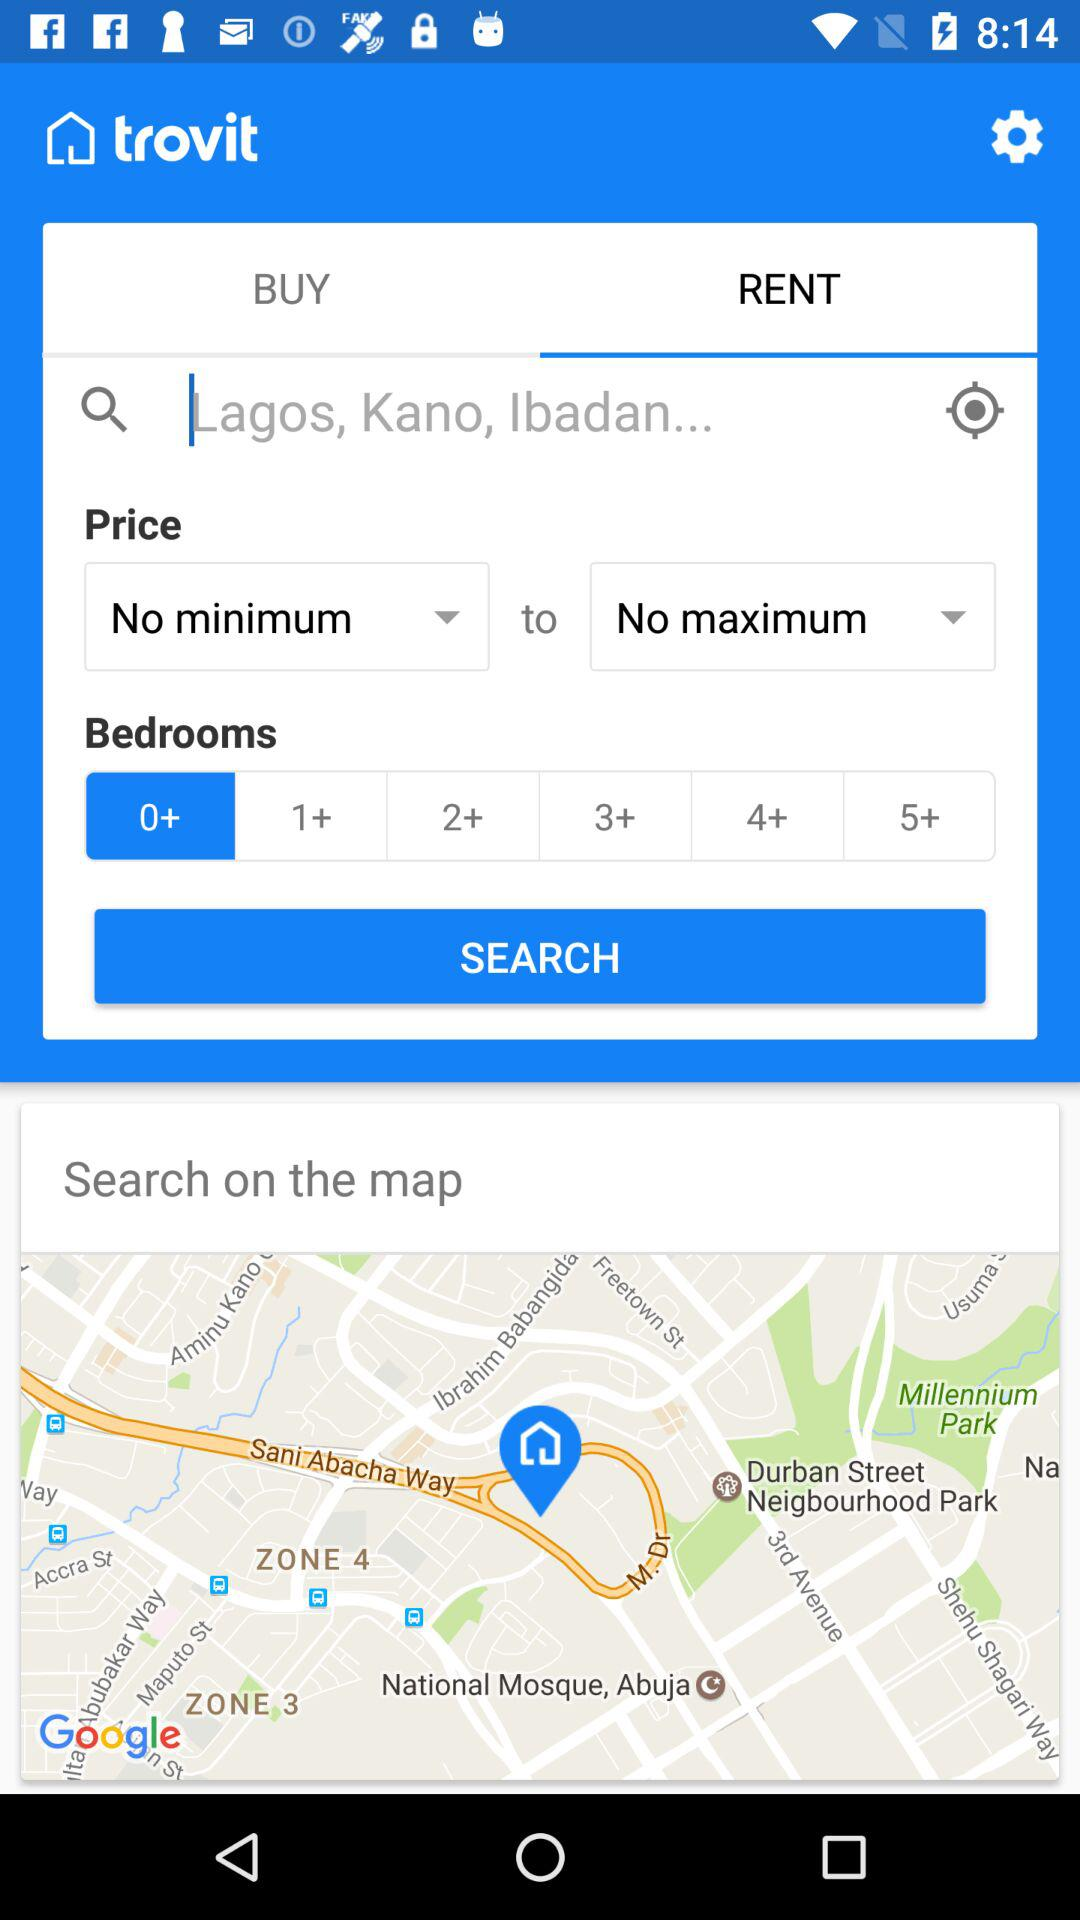How many more bedrooms can be selected than minimum price?
Answer the question using a single word or phrase. 5 